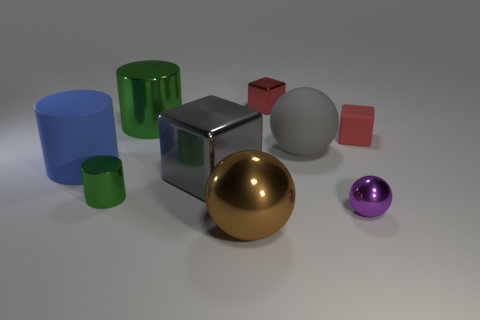What material is the big sphere in front of the green object on the left side of the large green object?
Give a very brief answer. Metal. What number of big blocks have the same color as the rubber ball?
Keep it short and to the point. 1. There is a red thing that is made of the same material as the small ball; what size is it?
Ensure brevity in your answer.  Small. The red thing behind the tiny matte block has what shape?
Provide a short and direct response. Cube. There is another metal thing that is the same shape as the large gray metal thing; what is its size?
Keep it short and to the point. Small. What number of large matte things are in front of the big matte object right of the metallic cylinder in front of the gray block?
Offer a very short reply. 1. Is the number of big rubber cylinders right of the blue cylinder the same as the number of big green metal cylinders?
Provide a short and direct response. No. What number of cylinders are either brown objects or big gray metallic objects?
Offer a very short reply. 0. Do the big metal cube and the matte ball have the same color?
Give a very brief answer. Yes. Are there the same number of small purple objects that are right of the tiny purple ball and blue rubber cylinders to the right of the large gray shiny block?
Offer a very short reply. Yes. 